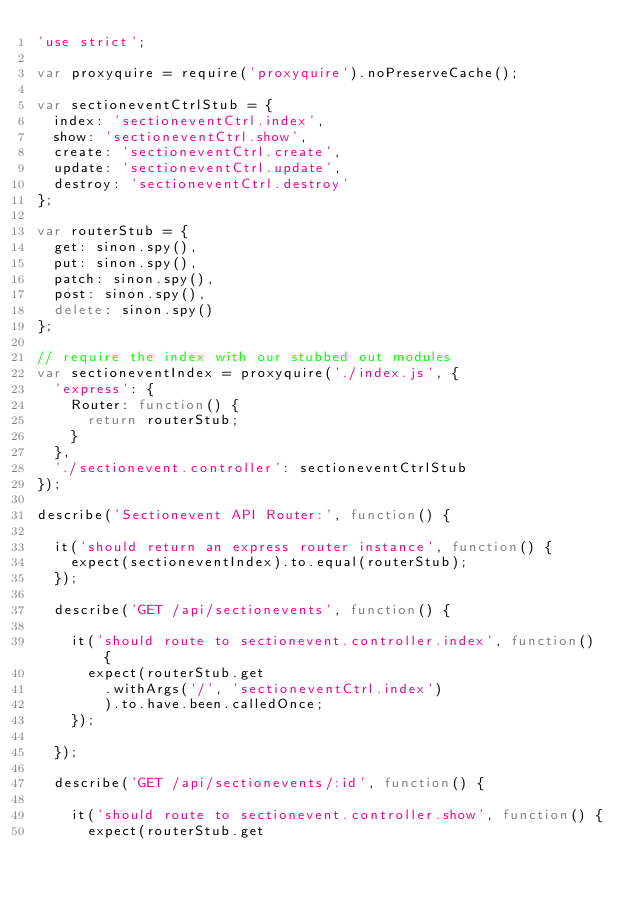<code> <loc_0><loc_0><loc_500><loc_500><_JavaScript_>'use strict';

var proxyquire = require('proxyquire').noPreserveCache();

var sectioneventCtrlStub = {
  index: 'sectioneventCtrl.index',
  show: 'sectioneventCtrl.show',
  create: 'sectioneventCtrl.create',
  update: 'sectioneventCtrl.update',
  destroy: 'sectioneventCtrl.destroy'
};

var routerStub = {
  get: sinon.spy(),
  put: sinon.spy(),
  patch: sinon.spy(),
  post: sinon.spy(),
  delete: sinon.spy()
};

// require the index with our stubbed out modules
var sectioneventIndex = proxyquire('./index.js', {
  'express': {
    Router: function() {
      return routerStub;
    }
  },
  './sectionevent.controller': sectioneventCtrlStub
});

describe('Sectionevent API Router:', function() {

  it('should return an express router instance', function() {
    expect(sectioneventIndex).to.equal(routerStub);
  });

  describe('GET /api/sectionevents', function() {

    it('should route to sectionevent.controller.index', function() {
      expect(routerStub.get
        .withArgs('/', 'sectioneventCtrl.index')
        ).to.have.been.calledOnce;
    });

  });

  describe('GET /api/sectionevents/:id', function() {

    it('should route to sectionevent.controller.show', function() {
      expect(routerStub.get</code> 